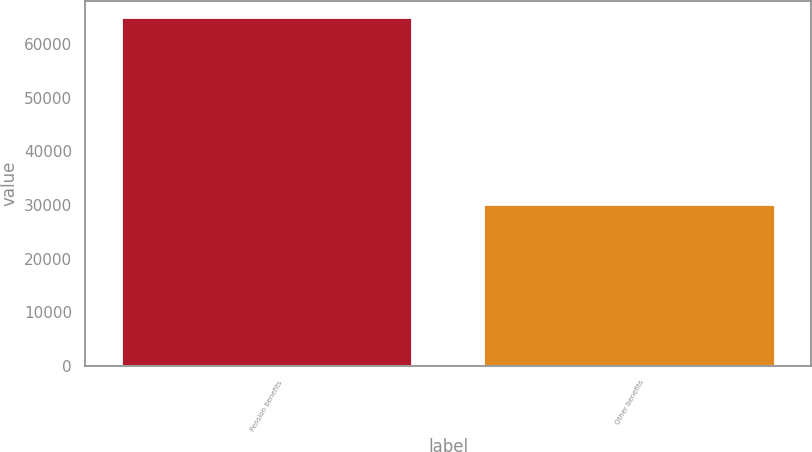Convert chart. <chart><loc_0><loc_0><loc_500><loc_500><bar_chart><fcel>Pension benefits<fcel>Other benefits<nl><fcel>64813<fcel>30078<nl></chart> 